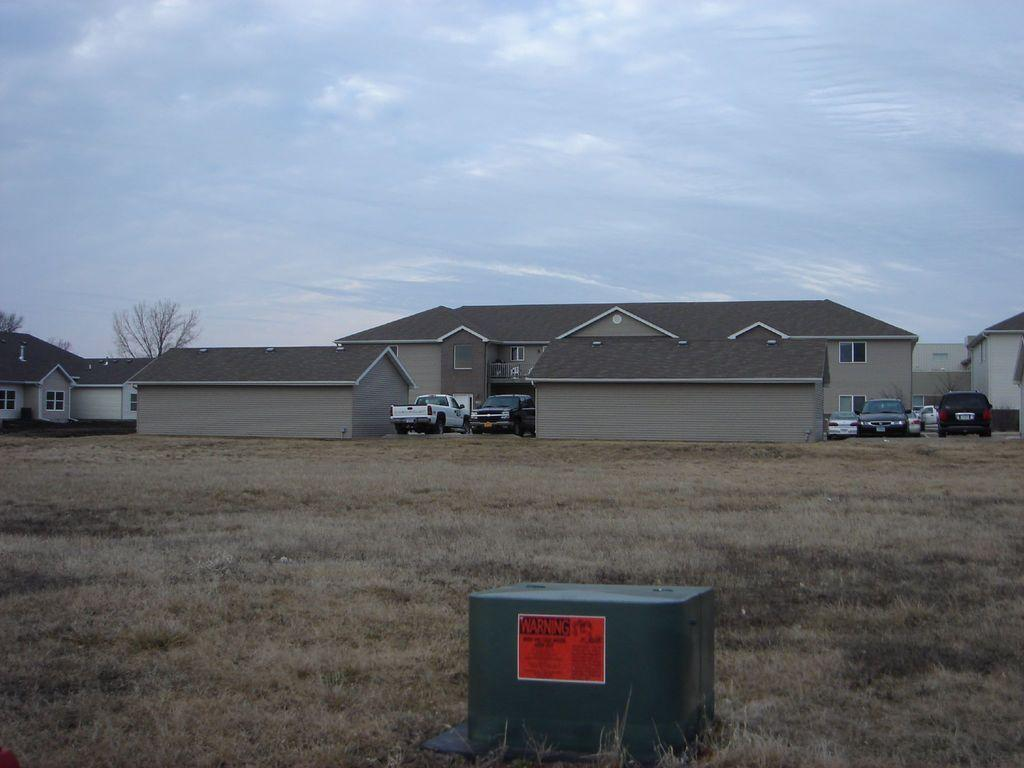What is the color of the paper attached to the object in the image? The paper attached to the object in the image is orange. What can be seen in the background of the image? There are vehicles and houses in the background of the image. What is the condition of the sky in the image? The sky is cloudy in the image. Can you see any seeds being planted in the image? There is no mention of seeds or planting in the image; it features an object with an orange paper attached to it, vehicles and houses in the background, and a cloudy sky. 